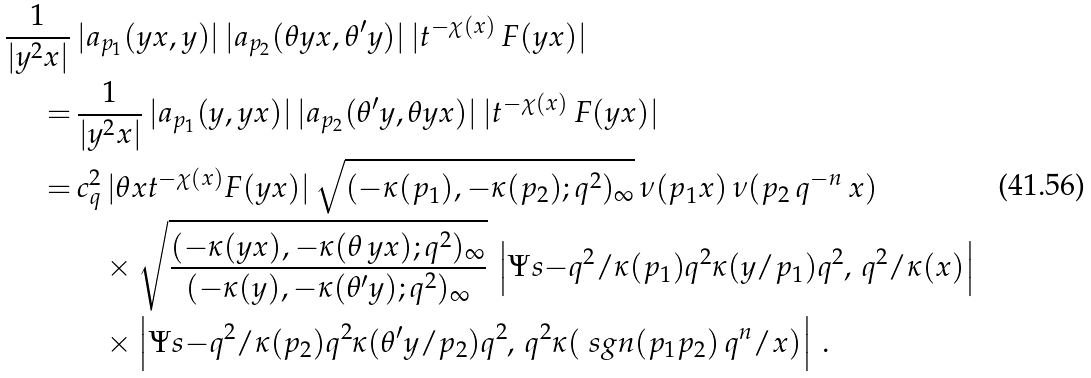Convert formula to latex. <formula><loc_0><loc_0><loc_500><loc_500>\frac { 1 } { | y ^ { 2 } x | } & \, | a _ { p _ { 1 } } ( y x , y ) | \, | a _ { p _ { 2 } } ( \theta y x , \theta ^ { \prime } y ) | \, | t ^ { - \chi ( x ) } \, F ( y x ) | \\ = & \, \frac { 1 } { | y ^ { 2 } x | } \, | a _ { p _ { 1 } } ( y , y x ) | \, | a _ { p _ { 2 } } ( \theta ^ { \prime } y , \theta y x ) | \, | t ^ { - \chi ( x ) } \, F ( y x ) | \\ = & \, c _ { q } ^ { 2 } \, | \theta x t ^ { - \chi ( x ) } F ( y x ) | \, \sqrt { ( - \kappa ( p _ { 1 } ) , - \kappa ( p _ { 2 } ) ; q ^ { 2 } ) _ { \infty } } \, \nu ( p _ { 1 } x ) \, \nu ( p _ { 2 } \, q ^ { - n } \, x ) \, \\ & \quad \times \sqrt { \frac { ( - \kappa ( y x ) , - \kappa ( \theta \, y x ) ; q ^ { 2 } ) _ { \infty } } { ( - \kappa ( y ) , - \kappa ( \theta ^ { \prime } y ) ; q ^ { 2 } ) _ { \infty } } } \, \left | \Psi s { - q ^ { 2 } / \kappa ( p _ { 1 } ) } { q ^ { 2 } \kappa ( y / p _ { 1 } ) } { q ^ { 2 } , \, q ^ { 2 } / \kappa ( x ) } \right | \ \\ & \quad \times \left | \Psi s { - q ^ { 2 } / \kappa ( p _ { 2 } ) } { q ^ { 2 } \kappa ( \theta ^ { \prime } y / p _ { 2 } ) } { q ^ { 2 } , \, q ^ { 2 } \kappa ( \ s g n ( p _ { 1 } p _ { 2 } ) \, q ^ { n } / x ) } \right | \, .</formula> 